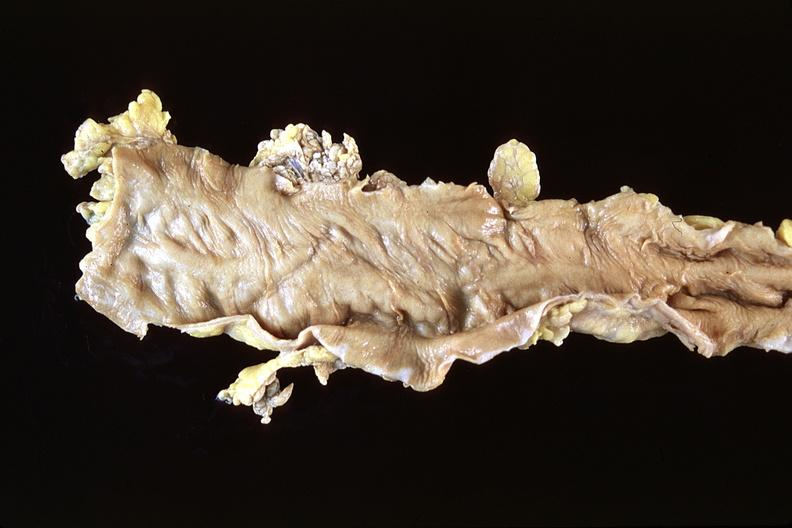does this typical thecoma with yellow foci show normal colon?
Answer the question using a single word or phrase. No 